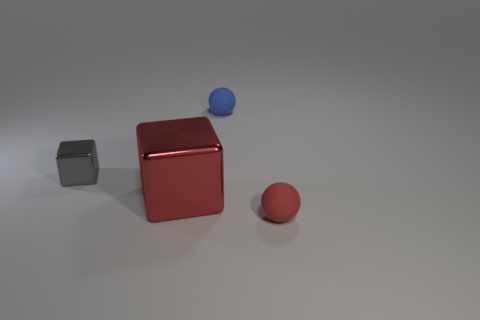Add 1 tiny green cylinders. How many objects exist? 5 Subtract 0 cyan cubes. How many objects are left? 4 Subtract all tiny red rubber balls. Subtract all purple shiny objects. How many objects are left? 3 Add 3 red things. How many red things are left? 5 Add 2 big red cubes. How many big red cubes exist? 3 